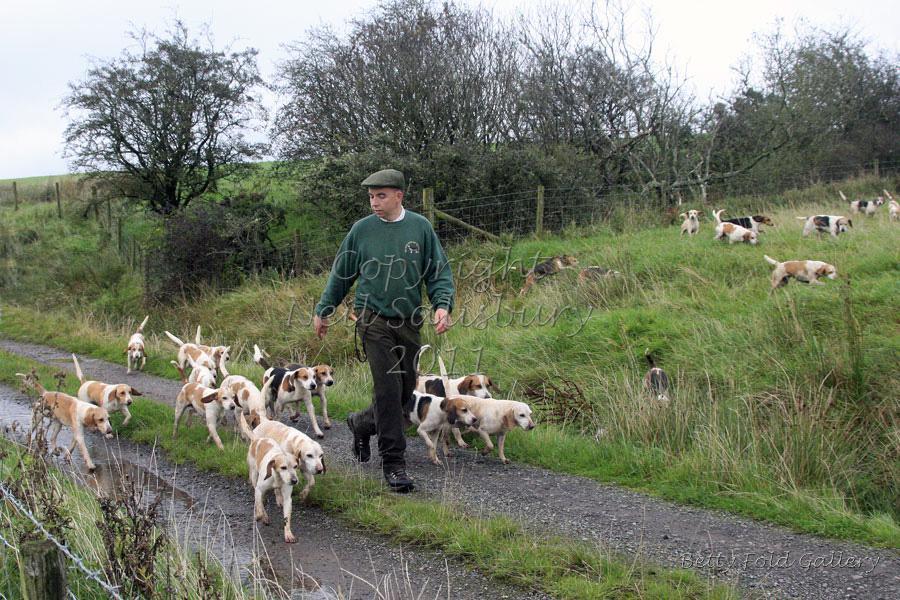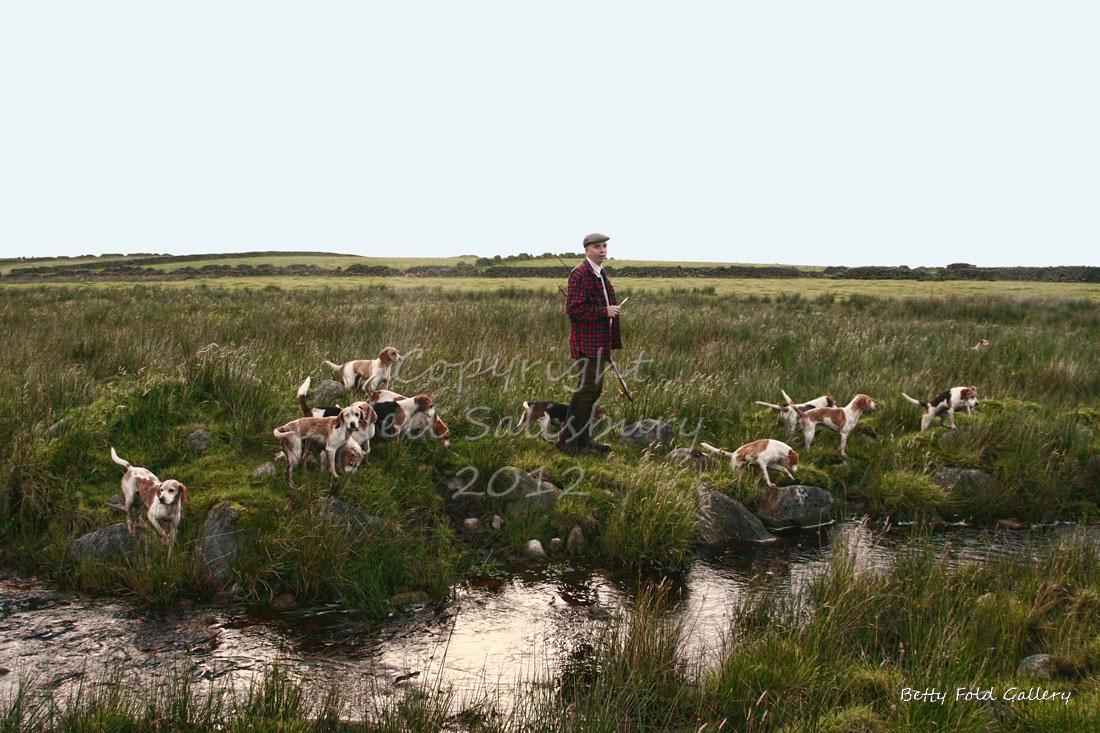The first image is the image on the left, the second image is the image on the right. Analyze the images presented: Is the assertion "there is exactly one person in the image on the left" valid? Answer yes or no. Yes. The first image is the image on the left, the second image is the image on the right. For the images shown, is this caption "There are dogs near a vehicle parked on the roadway." true? Answer yes or no. No. 